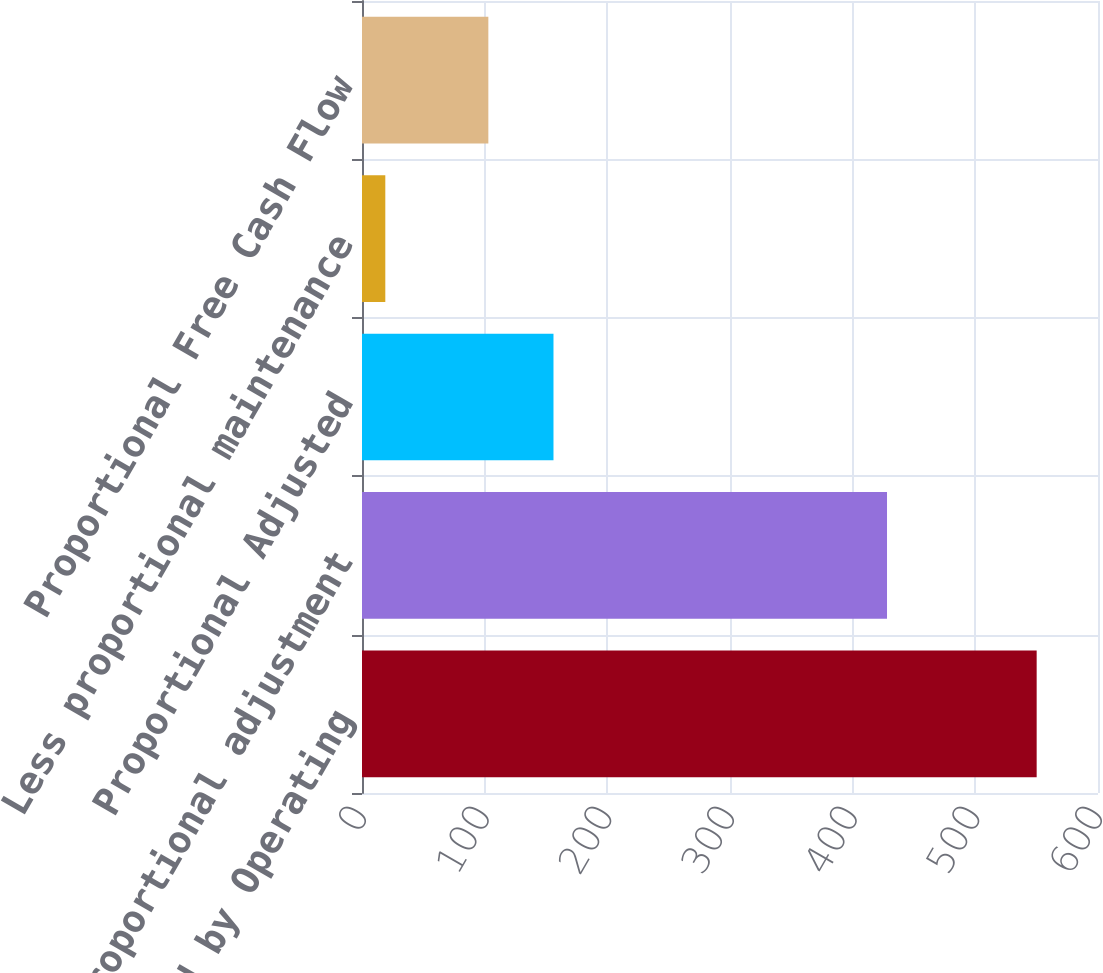Convert chart to OTSL. <chart><loc_0><loc_0><loc_500><loc_500><bar_chart><fcel>Net Cash Provided by Operating<fcel>Less proportional adjustment<fcel>Proportional Adjusted<fcel>Less proportional maintenance<fcel>Proportional Free Cash Flow<nl><fcel>550<fcel>428<fcel>156.1<fcel>19<fcel>103<nl></chart> 